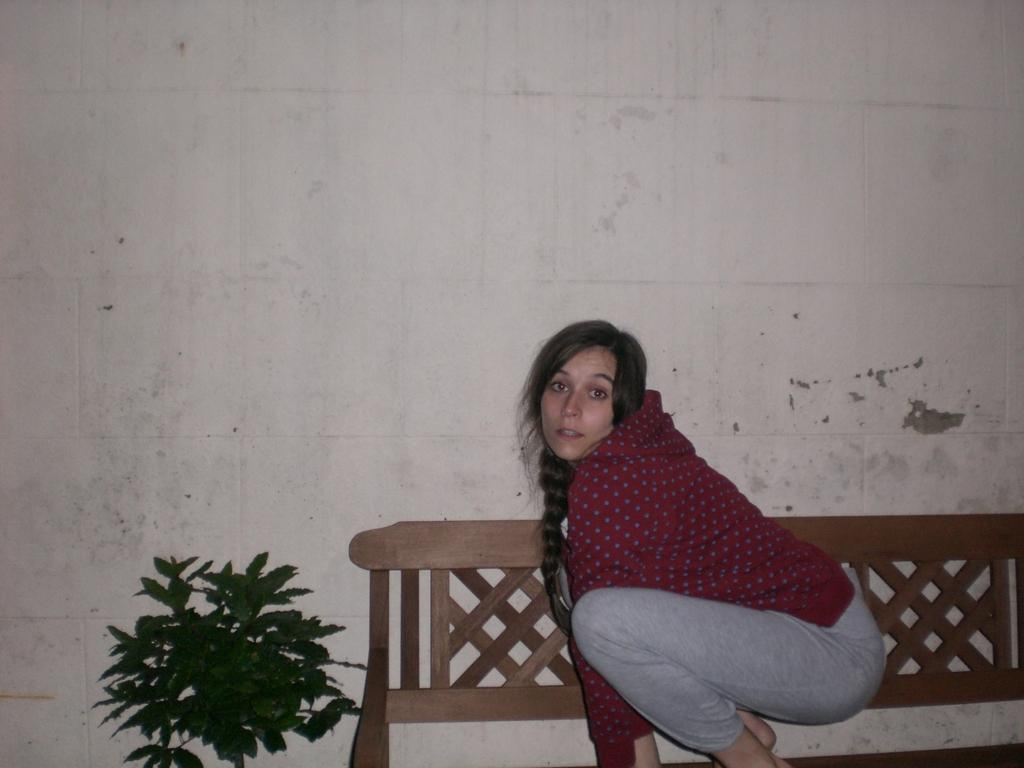Where is the woman located in the image? The woman is sitting on a bench on the right side of the image. What direction is the woman facing? The woman is facing towards the left side. What is the woman looking at? The woman is looking at a picture. What can be seen beside the bench? There is a plant beside the bench. What is visible in the background of the image? There is a wall in the background of the image. What type of liquid is being poured by the creator in the image? There is no creator or liquid present in the image; it features a woman sitting on a bench looking at a picture. 